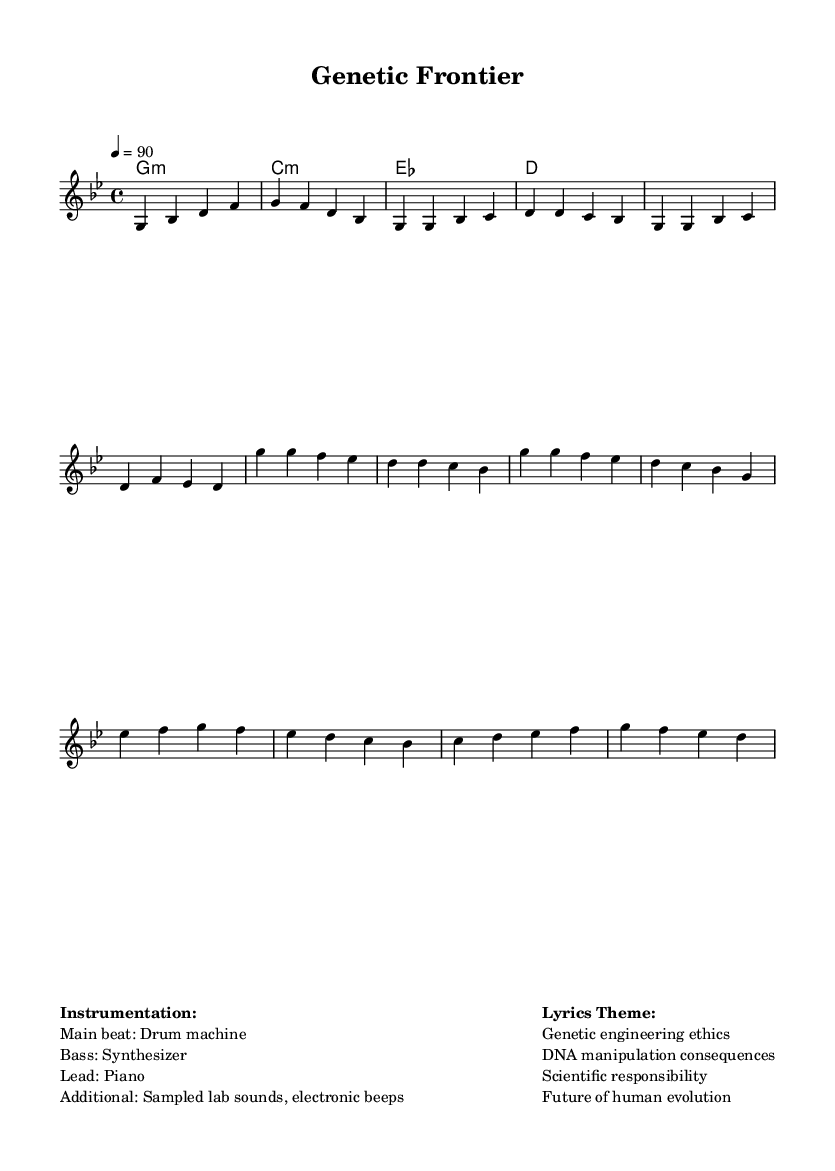What is the key signature of this music? The key signature is G minor, indicated by two flats (B flat and E flat). You can see this at the beginning of the score.
Answer: G minor What is the time signature of this music? The time signature is 4/4, which indicates four beats per measure. It's found at the beginning of the score next to the key signature.
Answer: 4/4 What is the tempo marking for this piece? The tempo marking is 4 = 90, which means there are 90 beats per minute. This indicates a moderate pace. This is indicated in the tempo section of the score.
Answer: 90 How many measures are in the verse section? The verse section contains four measures as it has four distinct phrases of music represented in the notation.
Answer: 4 What instrumentation is used in this piece? The piece features a drum machine for the main beat, a synthesizer for the bass, and a piano for the lead section. Additional sounds include sampled lab sounds and electronic beeps, provided in the instrumentation markup.
Answer: Drum machine, synthesizer, piano What lyrical themes are addressed in this music? The lyrical themes address topics such as genetic engineering ethics, the consequences of DNA manipulation, scientific responsibility, and the future of human evolution. These themes are outlined in the markup section as the lyrics theme.
Answer: Genetic engineering ethics 